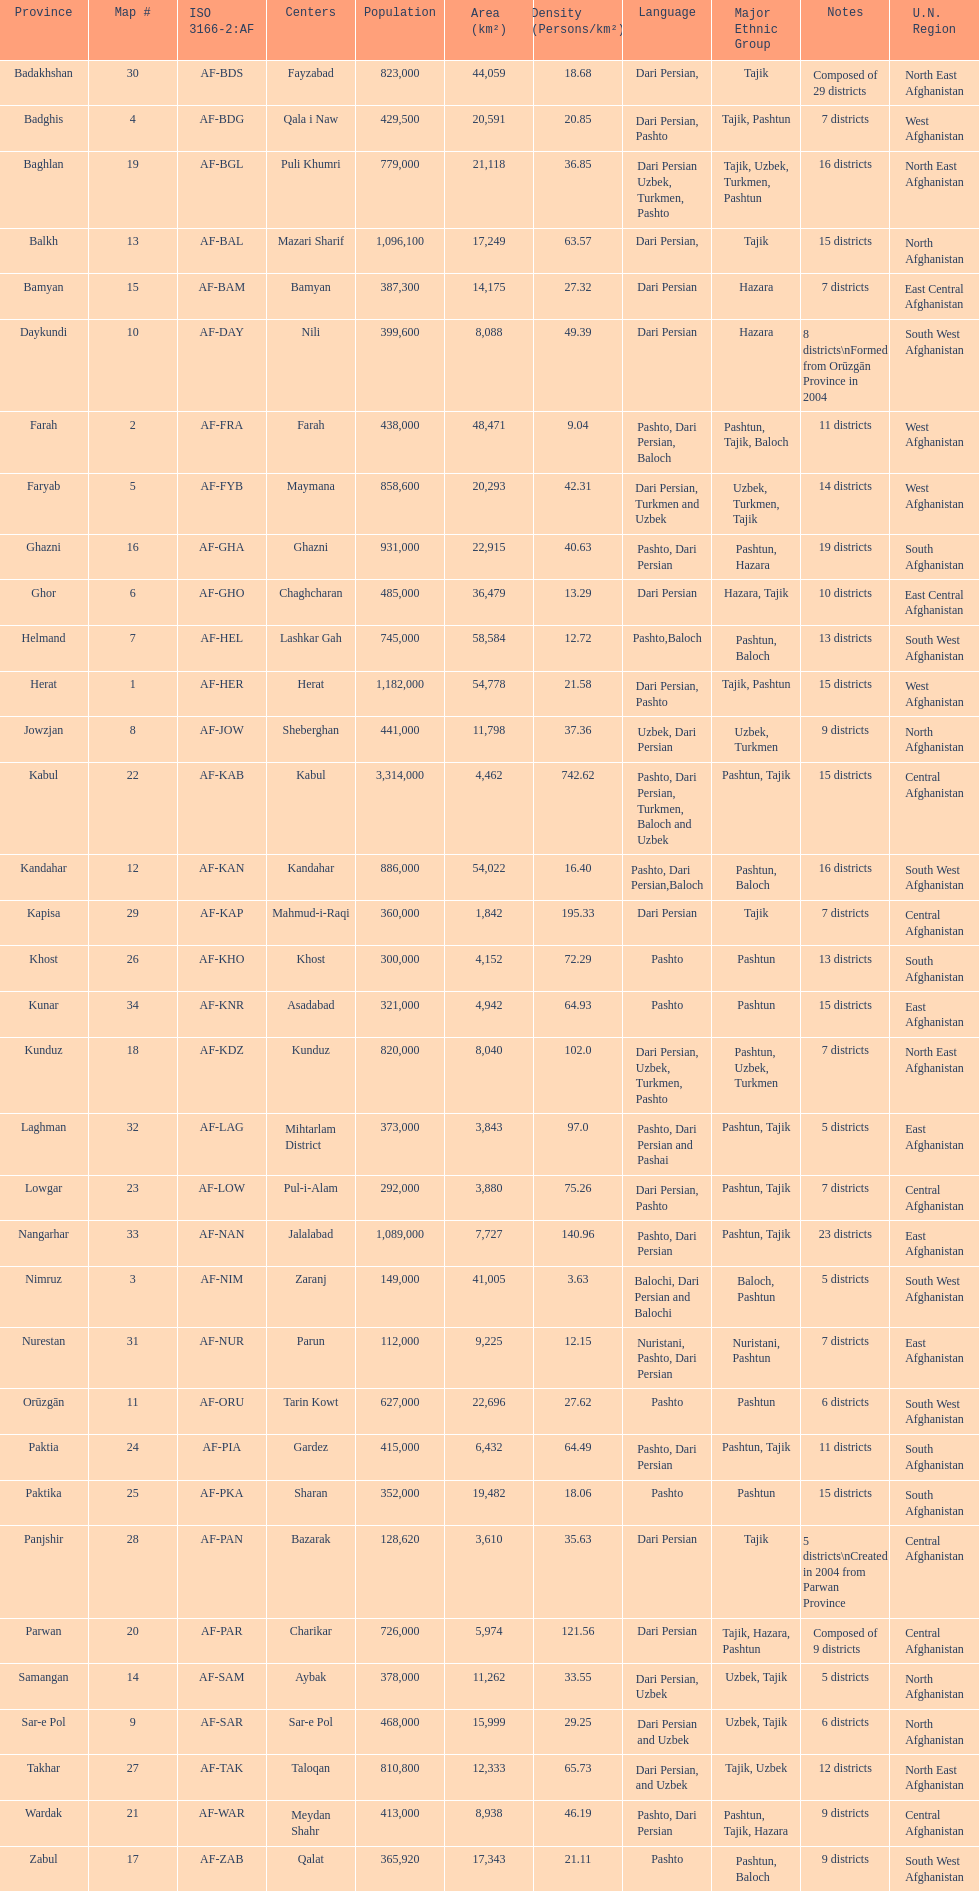Can you parse all the data within this table? {'header': ['Province', 'Map #', 'ISO 3166-2:AF', 'Centers', 'Population', 'Area (km²)', 'Density (Persons/km²)', 'Language', 'Major Ethnic Group', 'Notes', 'U.N. Region'], 'rows': [['Badakhshan', '30', 'AF-BDS', 'Fayzabad', '823,000', '44,059', '18.68', 'Dari Persian,', 'Tajik', 'Composed of 29 districts', 'North East Afghanistan'], ['Badghis', '4', 'AF-BDG', 'Qala i Naw', '429,500', '20,591', '20.85', 'Dari Persian, Pashto', 'Tajik, Pashtun', '7 districts', 'West Afghanistan'], ['Baghlan', '19', 'AF-BGL', 'Puli Khumri', '779,000', '21,118', '36.85', 'Dari Persian Uzbek, Turkmen, Pashto', 'Tajik, Uzbek, Turkmen, Pashtun', '16 districts', 'North East Afghanistan'], ['Balkh', '13', 'AF-BAL', 'Mazari Sharif', '1,096,100', '17,249', '63.57', 'Dari Persian,', 'Tajik', '15 districts', 'North Afghanistan'], ['Bamyan', '15', 'AF-BAM', 'Bamyan', '387,300', '14,175', '27.32', 'Dari Persian', 'Hazara', '7 districts', 'East Central Afghanistan'], ['Daykundi', '10', 'AF-DAY', 'Nili', '399,600', '8,088', '49.39', 'Dari Persian', 'Hazara', '8 districts\\nFormed from Orūzgān Province in 2004', 'South West Afghanistan'], ['Farah', '2', 'AF-FRA', 'Farah', '438,000', '48,471', '9.04', 'Pashto, Dari Persian, Baloch', 'Pashtun, Tajik, Baloch', '11 districts', 'West Afghanistan'], ['Faryab', '5', 'AF-FYB', 'Maymana', '858,600', '20,293', '42.31', 'Dari Persian, Turkmen and Uzbek', 'Uzbek, Turkmen, Tajik', '14 districts', 'West Afghanistan'], ['Ghazni', '16', 'AF-GHA', 'Ghazni', '931,000', '22,915', '40.63', 'Pashto, Dari Persian', 'Pashtun, Hazara', '19 districts', 'South Afghanistan'], ['Ghor', '6', 'AF-GHO', 'Chaghcharan', '485,000', '36,479', '13.29', 'Dari Persian', 'Hazara, Tajik', '10 districts', 'East Central Afghanistan'], ['Helmand', '7', 'AF-HEL', 'Lashkar Gah', '745,000', '58,584', '12.72', 'Pashto,Baloch', 'Pashtun, Baloch', '13 districts', 'South West Afghanistan'], ['Herat', '1', 'AF-HER', 'Herat', '1,182,000', '54,778', '21.58', 'Dari Persian, Pashto', 'Tajik, Pashtun', '15 districts', 'West Afghanistan'], ['Jowzjan', '8', 'AF-JOW', 'Sheberghan', '441,000', '11,798', '37.36', 'Uzbek, Dari Persian', 'Uzbek, Turkmen', '9 districts', 'North Afghanistan'], ['Kabul', '22', 'AF-KAB', 'Kabul', '3,314,000', '4,462', '742.62', 'Pashto, Dari Persian, Turkmen, Baloch and Uzbek', 'Pashtun, Tajik', '15 districts', 'Central Afghanistan'], ['Kandahar', '12', 'AF-KAN', 'Kandahar', '886,000', '54,022', '16.40', 'Pashto, Dari Persian,Baloch', 'Pashtun, Baloch', '16 districts', 'South West Afghanistan'], ['Kapisa', '29', 'AF-KAP', 'Mahmud-i-Raqi', '360,000', '1,842', '195.33', 'Dari Persian', 'Tajik', '7 districts', 'Central Afghanistan'], ['Khost', '26', 'AF-KHO', 'Khost', '300,000', '4,152', '72.29', 'Pashto', 'Pashtun', '13 districts', 'South Afghanistan'], ['Kunar', '34', 'AF-KNR', 'Asadabad', '321,000', '4,942', '64.93', 'Pashto', 'Pashtun', '15 districts', 'East Afghanistan'], ['Kunduz', '18', 'AF-KDZ', 'Kunduz', '820,000', '8,040', '102.0', 'Dari Persian, Uzbek, Turkmen, Pashto', 'Pashtun, Uzbek, Turkmen', '7 districts', 'North East Afghanistan'], ['Laghman', '32', 'AF-LAG', 'Mihtarlam District', '373,000', '3,843', '97.0', 'Pashto, Dari Persian and Pashai', 'Pashtun, Tajik', '5 districts', 'East Afghanistan'], ['Lowgar', '23', 'AF-LOW', 'Pul-i-Alam', '292,000', '3,880', '75.26', 'Dari Persian, Pashto', 'Pashtun, Tajik', '7 districts', 'Central Afghanistan'], ['Nangarhar', '33', 'AF-NAN', 'Jalalabad', '1,089,000', '7,727', '140.96', 'Pashto, Dari Persian', 'Pashtun, Tajik', '23 districts', 'East Afghanistan'], ['Nimruz', '3', 'AF-NIM', 'Zaranj', '149,000', '41,005', '3.63', 'Balochi, Dari Persian and Balochi', 'Baloch, Pashtun', '5 districts', 'South West Afghanistan'], ['Nurestan', '31', 'AF-NUR', 'Parun', '112,000', '9,225', '12.15', 'Nuristani, Pashto, Dari Persian', 'Nuristani, Pashtun', '7 districts', 'East Afghanistan'], ['Orūzgān', '11', 'AF-ORU', 'Tarin Kowt', '627,000', '22,696', '27.62', 'Pashto', 'Pashtun', '6 districts', 'South West Afghanistan'], ['Paktia', '24', 'AF-PIA', 'Gardez', '415,000', '6,432', '64.49', 'Pashto, Dari Persian', 'Pashtun, Tajik', '11 districts', 'South Afghanistan'], ['Paktika', '25', 'AF-PKA', 'Sharan', '352,000', '19,482', '18.06', 'Pashto', 'Pashtun', '15 districts', 'South Afghanistan'], ['Panjshir', '28', 'AF-PAN', 'Bazarak', '128,620', '3,610', '35.63', 'Dari Persian', 'Tajik', '5 districts\\nCreated in 2004 from Parwan Province', 'Central Afghanistan'], ['Parwan', '20', 'AF-PAR', 'Charikar', '726,000', '5,974', '121.56', 'Dari Persian', 'Tajik, Hazara, Pashtun', 'Composed of 9 districts', 'Central Afghanistan'], ['Samangan', '14', 'AF-SAM', 'Aybak', '378,000', '11,262', '33.55', 'Dari Persian, Uzbek', 'Uzbek, Tajik', '5 districts', 'North Afghanistan'], ['Sar-e Pol', '9', 'AF-SAR', 'Sar-e Pol', '468,000', '15,999', '29.25', 'Dari Persian and Uzbek', 'Uzbek, Tajik', '6 districts', 'North Afghanistan'], ['Takhar', '27', 'AF-TAK', 'Taloqan', '810,800', '12,333', '65.73', 'Dari Persian, and Uzbek', 'Tajik, Uzbek', '12 districts', 'North East Afghanistan'], ['Wardak', '21', 'AF-WAR', 'Meydan Shahr', '413,000', '8,938', '46.19', 'Pashto, Dari Persian', 'Pashtun, Tajik, Hazara', '9 districts', 'Central Afghanistan'], ['Zabul', '17', 'AF-ZAB', 'Qalat', '365,920', '17,343', '21.11', 'Pashto', 'Pashtun, Baloch', '9 districts', 'South West Afghanistan']]} Give the province with the least population Nurestan. 